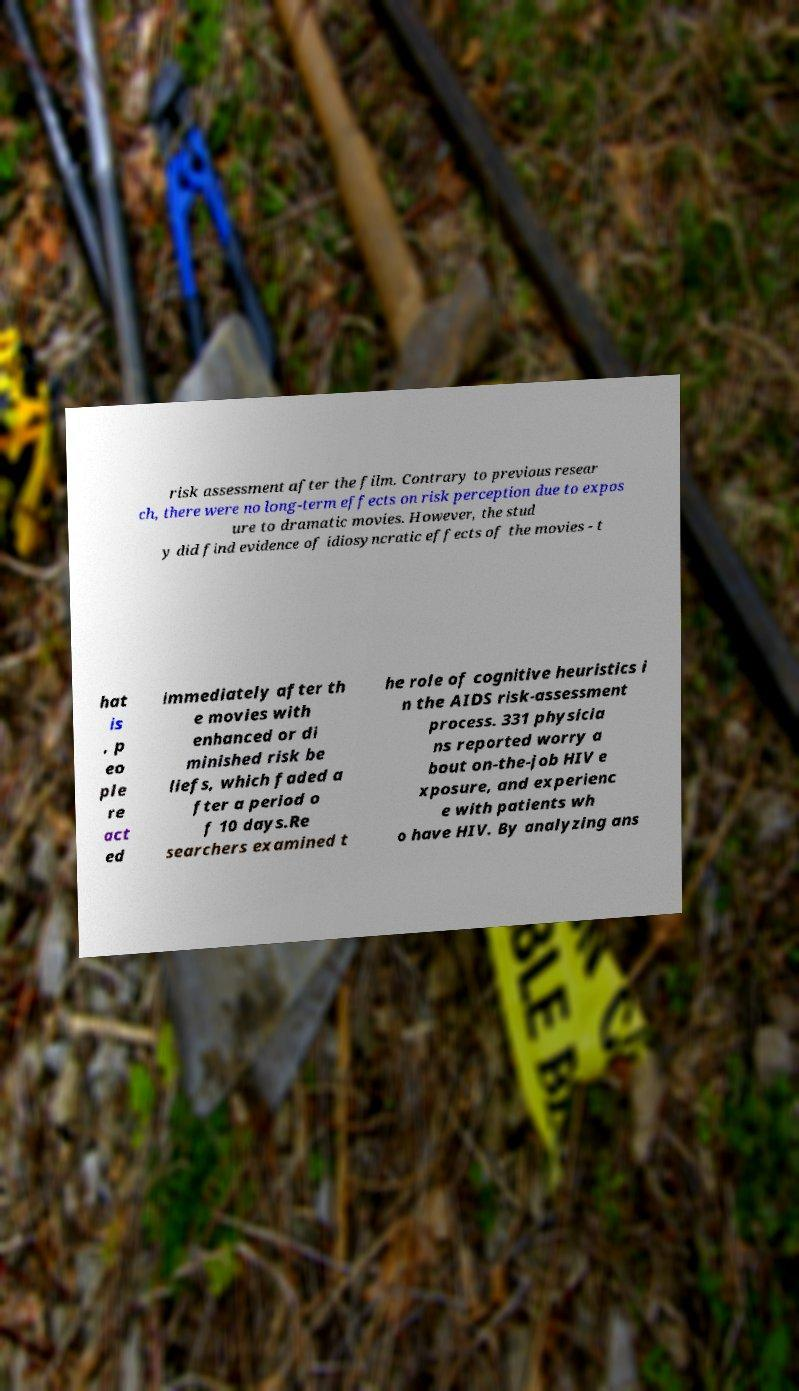I need the written content from this picture converted into text. Can you do that? risk assessment after the film. Contrary to previous resear ch, there were no long-term effects on risk perception due to expos ure to dramatic movies. However, the stud y did find evidence of idiosyncratic effects of the movies - t hat is , p eo ple re act ed immediately after th e movies with enhanced or di minished risk be liefs, which faded a fter a period o f 10 days.Re searchers examined t he role of cognitive heuristics i n the AIDS risk-assessment process. 331 physicia ns reported worry a bout on-the-job HIV e xposure, and experienc e with patients wh o have HIV. By analyzing ans 